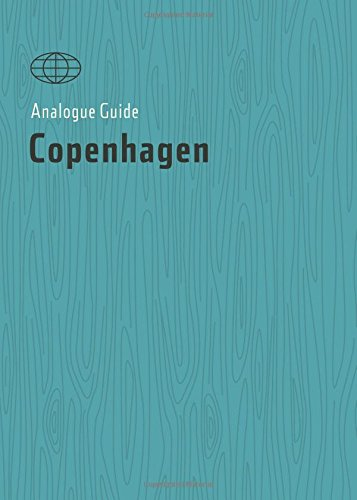Is this book related to Travel? Yes, this book is indeed related to travel, exploring Copenhagen through a unique and local perspective. 